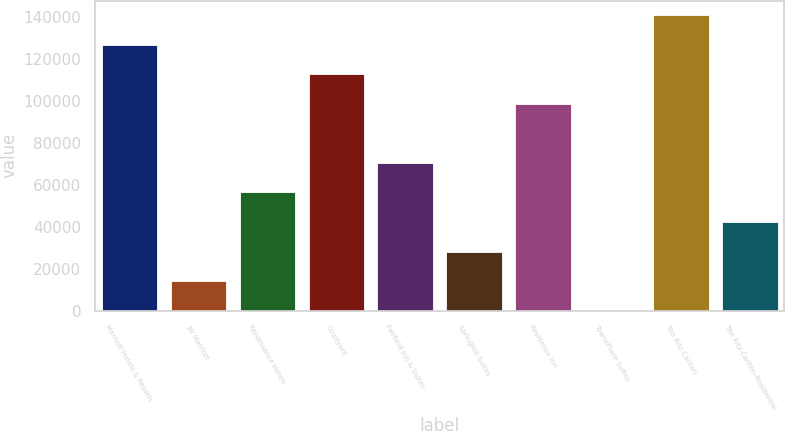<chart> <loc_0><loc_0><loc_500><loc_500><bar_chart><fcel>Marriott Hotels & Resorts<fcel>JW Marriott<fcel>Renaissance Hotels<fcel>Courtyard<fcel>Fairfield Inn & Suites<fcel>SpringHill Suites<fcel>Residence Inn<fcel>TownePlace Suites<fcel>The Ritz-Carlton<fcel>The Ritz-Carlton-Residential<nl><fcel>126813<fcel>14183.7<fcel>56419.8<fcel>112735<fcel>70498.5<fcel>28262.4<fcel>98655.9<fcel>105<fcel>140892<fcel>42341.1<nl></chart> 